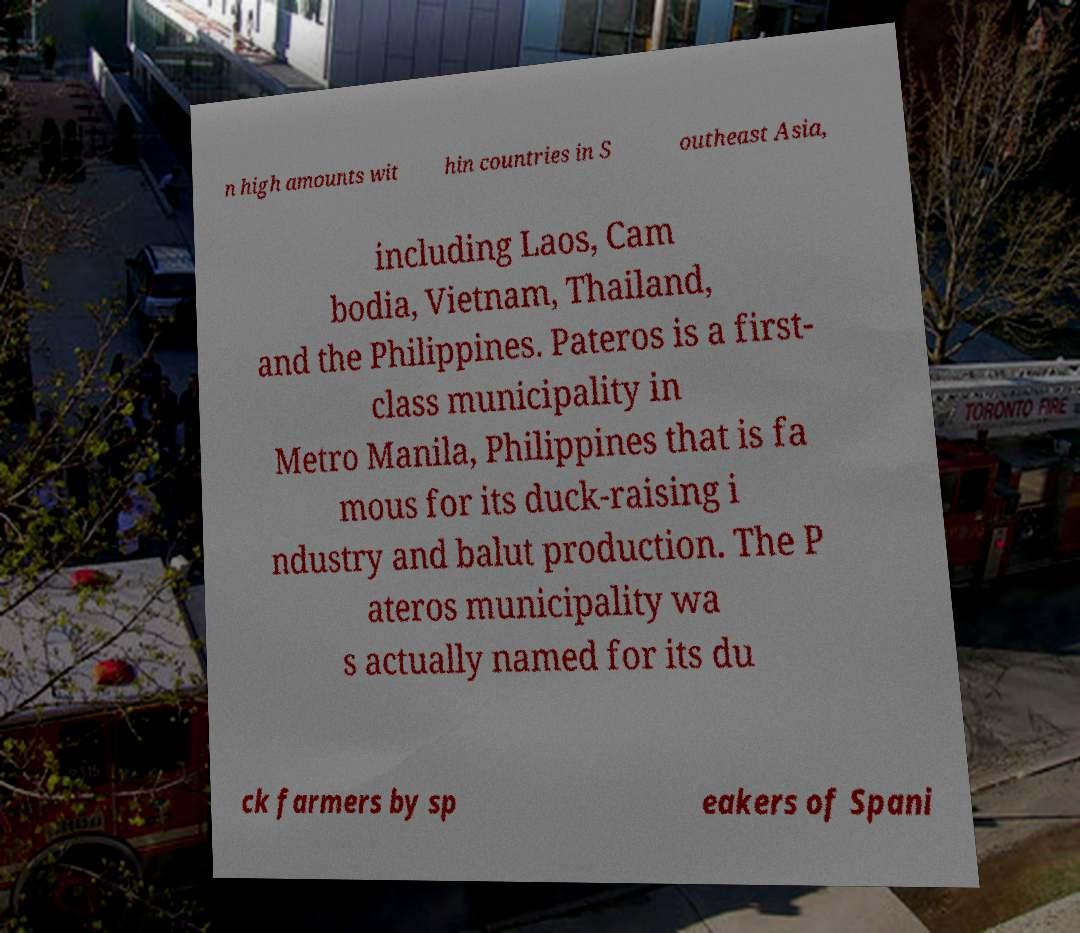Can you accurately transcribe the text from the provided image for me? n high amounts wit hin countries in S outheast Asia, including Laos, Cam bodia, Vietnam, Thailand, and the Philippines. Pateros is a first- class municipality in Metro Manila, Philippines that is fa mous for its duck-raising i ndustry and balut production. The P ateros municipality wa s actually named for its du ck farmers by sp eakers of Spani 